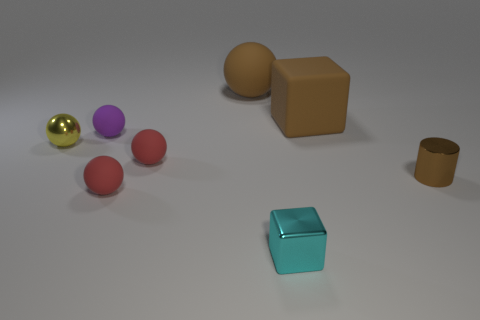The brown object in front of the big thing that is in front of the large brown sphere is what shape?
Offer a very short reply. Cylinder. Are any large matte spheres visible?
Provide a short and direct response. Yes. What is the color of the tiny rubber sphere behind the yellow metal sphere?
Offer a very short reply. Purple. What material is the large thing that is the same color as the big matte ball?
Offer a very short reply. Rubber. There is a small cylinder; are there any spheres in front of it?
Your answer should be compact. Yes. Are there more small blocks than red spheres?
Keep it short and to the point. No. There is a small sphere that is to the left of the small matte thing behind the thing left of the tiny purple rubber ball; what color is it?
Make the answer very short. Yellow. There is a small cylinder that is made of the same material as the tiny cyan thing; what color is it?
Your answer should be compact. Brown. Is there anything else that is the same size as the yellow thing?
Your response must be concise. Yes. What number of things are either large things in front of the brown sphere or metal objects to the right of the purple rubber sphere?
Your answer should be compact. 3. 